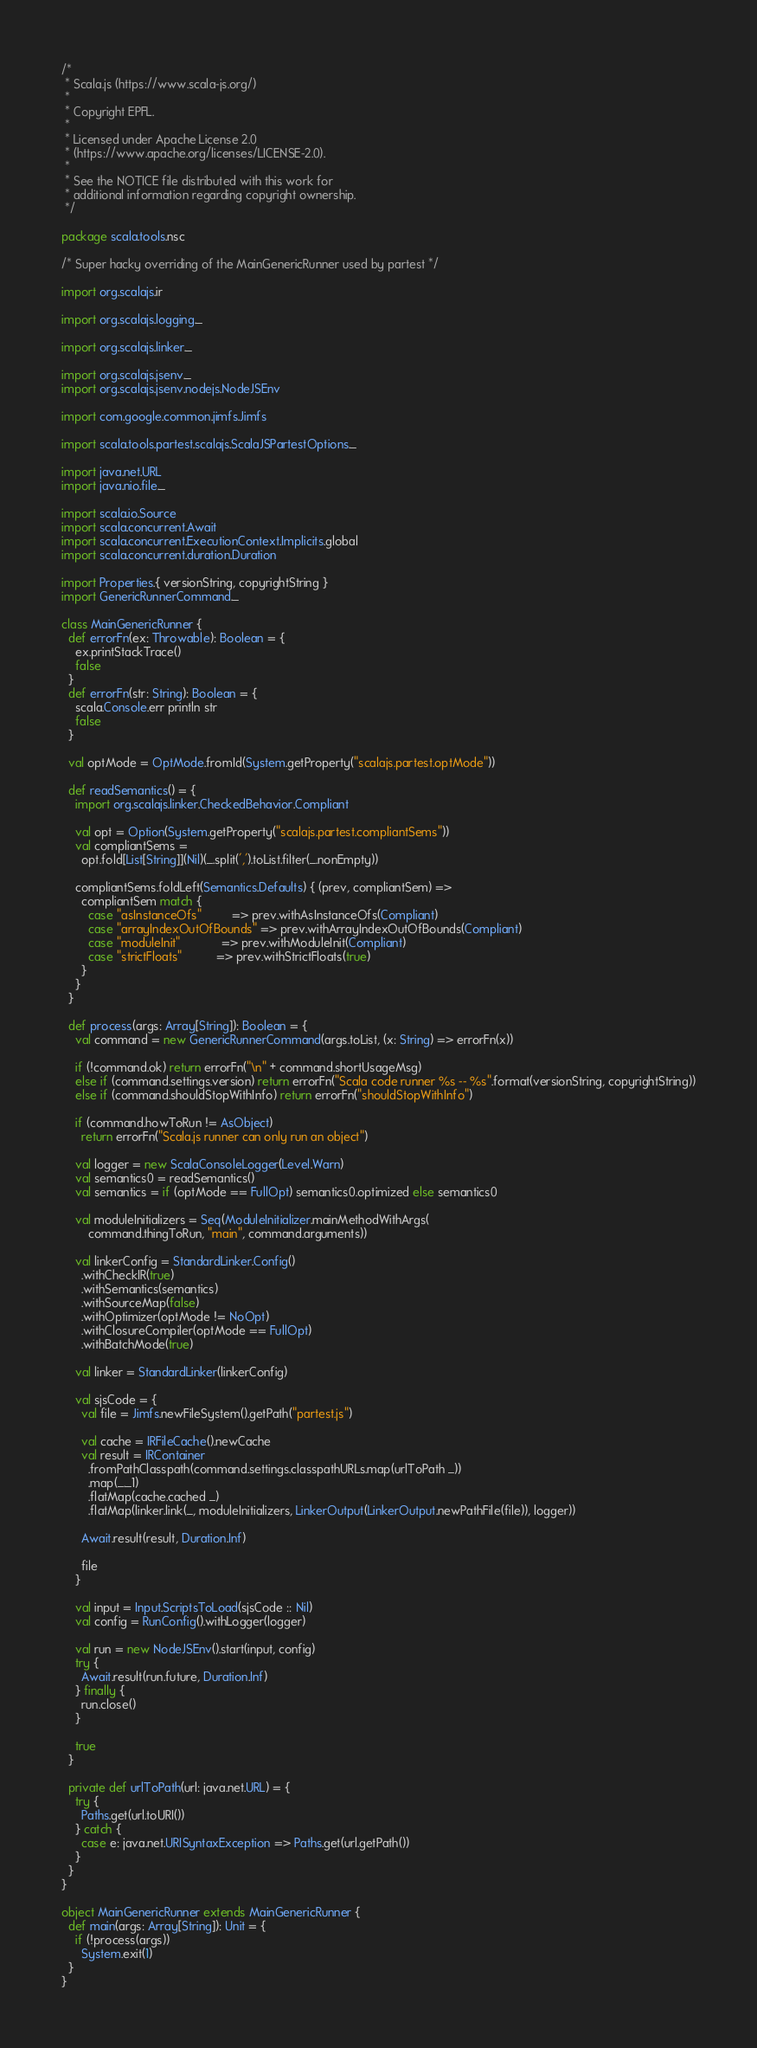Convert code to text. <code><loc_0><loc_0><loc_500><loc_500><_Scala_>/*
 * Scala.js (https://www.scala-js.org/)
 *
 * Copyright EPFL.
 *
 * Licensed under Apache License 2.0
 * (https://www.apache.org/licenses/LICENSE-2.0).
 *
 * See the NOTICE file distributed with this work for
 * additional information regarding copyright ownership.
 */

package scala.tools.nsc

/* Super hacky overriding of the MainGenericRunner used by partest */

import org.scalajs.ir

import org.scalajs.logging._

import org.scalajs.linker._

import org.scalajs.jsenv._
import org.scalajs.jsenv.nodejs.NodeJSEnv

import com.google.common.jimfs.Jimfs

import scala.tools.partest.scalajs.ScalaJSPartestOptions._

import java.net.URL
import java.nio.file._

import scala.io.Source
import scala.concurrent.Await
import scala.concurrent.ExecutionContext.Implicits.global
import scala.concurrent.duration.Duration

import Properties.{ versionString, copyrightString }
import GenericRunnerCommand._

class MainGenericRunner {
  def errorFn(ex: Throwable): Boolean = {
    ex.printStackTrace()
    false
  }
  def errorFn(str: String): Boolean = {
    scala.Console.err println str
    false
  }

  val optMode = OptMode.fromId(System.getProperty("scalajs.partest.optMode"))

  def readSemantics() = {
    import org.scalajs.linker.CheckedBehavior.Compliant

    val opt = Option(System.getProperty("scalajs.partest.compliantSems"))
    val compliantSems =
      opt.fold[List[String]](Nil)(_.split(',').toList.filter(_.nonEmpty))

    compliantSems.foldLeft(Semantics.Defaults) { (prev, compliantSem) =>
      compliantSem match {
        case "asInstanceOfs"         => prev.withAsInstanceOfs(Compliant)
        case "arrayIndexOutOfBounds" => prev.withArrayIndexOutOfBounds(Compliant)
        case "moduleInit"            => prev.withModuleInit(Compliant)
        case "strictFloats"          => prev.withStrictFloats(true)
      }
    }
  }

  def process(args: Array[String]): Boolean = {
    val command = new GenericRunnerCommand(args.toList, (x: String) => errorFn(x))

    if (!command.ok) return errorFn("\n" + command.shortUsageMsg)
    else if (command.settings.version) return errorFn("Scala code runner %s -- %s".format(versionString, copyrightString))
    else if (command.shouldStopWithInfo) return errorFn("shouldStopWithInfo")

    if (command.howToRun != AsObject)
      return errorFn("Scala.js runner can only run an object")

    val logger = new ScalaConsoleLogger(Level.Warn)
    val semantics0 = readSemantics()
    val semantics = if (optMode == FullOpt) semantics0.optimized else semantics0

    val moduleInitializers = Seq(ModuleInitializer.mainMethodWithArgs(
        command.thingToRun, "main", command.arguments))

    val linkerConfig = StandardLinker.Config()
      .withCheckIR(true)
      .withSemantics(semantics)
      .withSourceMap(false)
      .withOptimizer(optMode != NoOpt)
      .withClosureCompiler(optMode == FullOpt)
      .withBatchMode(true)

    val linker = StandardLinker(linkerConfig)

    val sjsCode = {
      val file = Jimfs.newFileSystem().getPath("partest.js")

      val cache = IRFileCache().newCache
      val result = IRContainer
        .fromPathClasspath(command.settings.classpathURLs.map(urlToPath _))
        .map(_._1)
        .flatMap(cache.cached _)
        .flatMap(linker.link(_, moduleInitializers, LinkerOutput(LinkerOutput.newPathFile(file)), logger))

      Await.result(result, Duration.Inf)

      file
    }

    val input = Input.ScriptsToLoad(sjsCode :: Nil)
    val config = RunConfig().withLogger(logger)

    val run = new NodeJSEnv().start(input, config)
    try {
      Await.result(run.future, Duration.Inf)
    } finally {
      run.close()
    }

    true
  }

  private def urlToPath(url: java.net.URL) = {
    try {
      Paths.get(url.toURI())
    } catch {
      case e: java.net.URISyntaxException => Paths.get(url.getPath())
    }
  }
}

object MainGenericRunner extends MainGenericRunner {
  def main(args: Array[String]): Unit = {
    if (!process(args))
      System.exit(1)
  }
}
</code> 